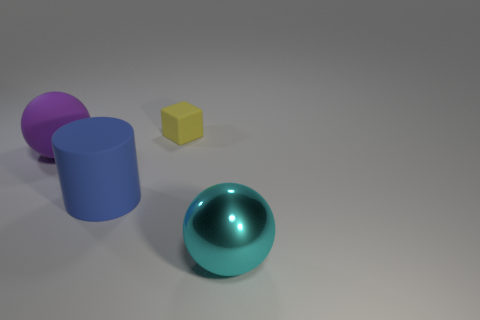Can you describe the lighting in the image? Certainly. The lighting in the image is soft and diffused, creating gentle shadows on the right side of the objects, suggesting a light source to the left side of the frame. There are no harsh highlights, and the shadows are not very dark, which indicates that the lighting setup was carefully controlled to avoid deep contrasts, giving the scene an evenly lit, calm appearance. Does the shadow direction tell us anything else? Yes, the direction of the shadows provides clues about the position and possibly the size of the light source. Given that the shadows cast by each object extend directly to the right, we can deduce that the light source is not only to the left but also slightly above the level of the objects. The soft edge of the shadows could also imply that the light source is not extremely close to the objects, which allows the shadows to gently fade without sharp edges. 